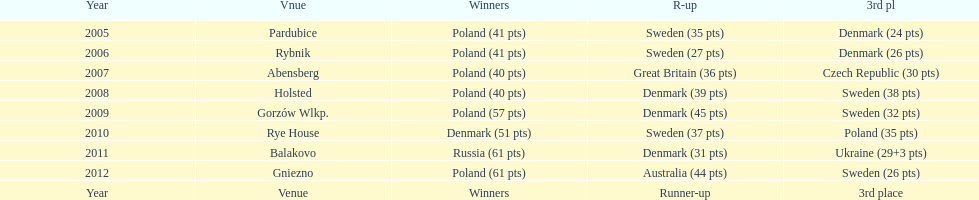After enjoying five consecutive victories at the team speedway junior world championship poland was finally unseated in what year? 2010. In that year, what teams placed first through third? Denmark (51 pts), Sweden (37 pts), Poland (35 pts). Which of those positions did poland specifically place in? 3rd place. 